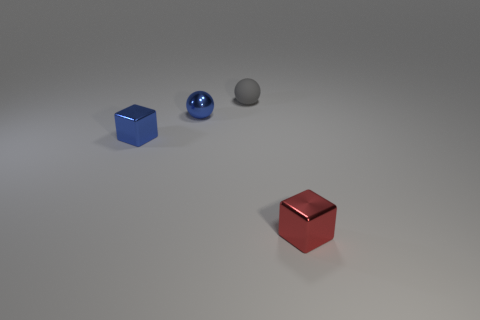Are there any other things that have the same material as the small gray sphere?
Give a very brief answer. No. What number of metal things are either small yellow things or small gray spheres?
Give a very brief answer. 0. There is a object in front of the small cube behind the red metal thing; what is its shape?
Provide a succinct answer. Cube. Is the number of small red metal things behind the blue cube less than the number of cyan rubber cylinders?
Give a very brief answer. No. There is a red thing; what shape is it?
Provide a succinct answer. Cube. What size is the sphere behind the metal ball?
Provide a short and direct response. Small. What is the color of the metallic ball that is the same size as the gray thing?
Give a very brief answer. Blue. Is there another metal ball of the same color as the tiny metal ball?
Give a very brief answer. No. Are there fewer metallic things that are right of the tiny blue cube than tiny gray rubber things that are in front of the gray matte sphere?
Offer a terse response. No. There is a small thing that is in front of the small rubber sphere and behind the tiny blue block; what material is it made of?
Your answer should be very brief. Metal. 